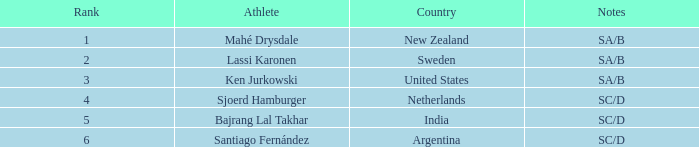What is the sum of the ranks for india? 5.0. 